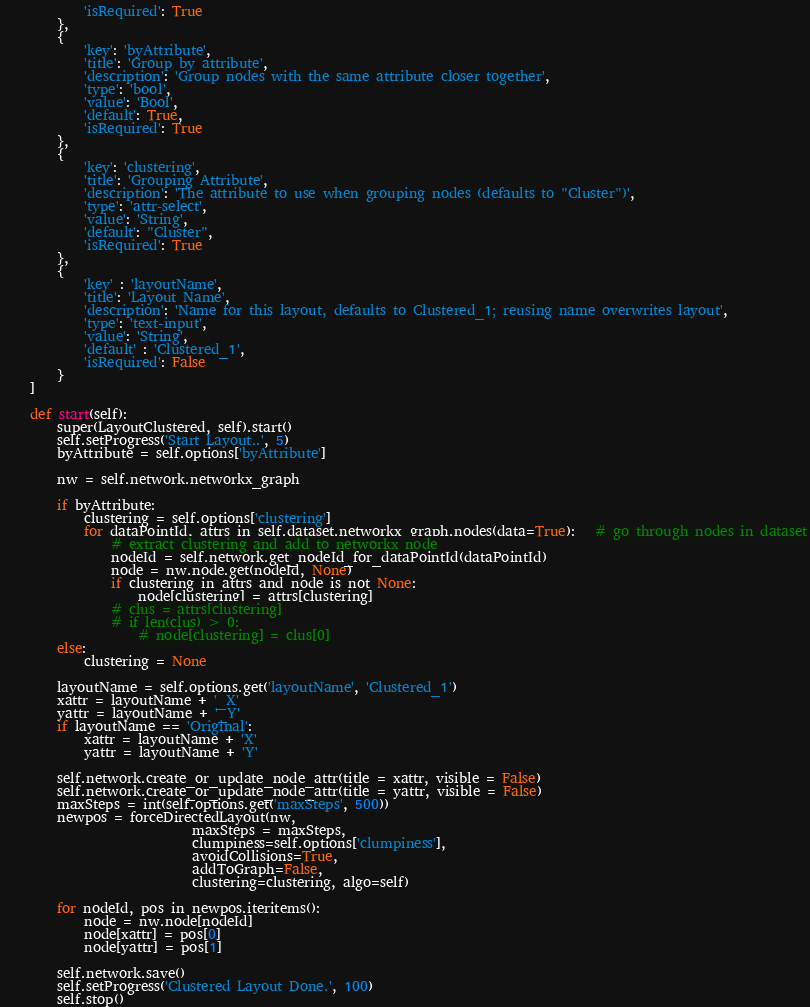<code> <loc_0><loc_0><loc_500><loc_500><_Python_>            'isRequired': True
        },
        {
            'key': 'byAttribute',
            'title': 'Group by attribute',
            'description': 'Group nodes with the same attribute closer together',
            'type': 'bool',
            'value': 'Bool',
            'default': True,
            'isRequired': True
        },
        {
            'key': 'clustering',
            'title': 'Grouping Attribute',
            'description': 'The attribute to use when grouping nodes (defaults to "Cluster")',
            'type': 'attr-select',
            'value': 'String',
            'default': "Cluster",
            'isRequired': True
        },
        {
            'key' : 'layoutName',
            'title': 'Layout Name',
            'description': 'Name for this layout, defaults to Clustered_1; reusing name overwrites layout',
            'type': 'text-input',
            'value': 'String',
            'default' : 'Clustered_1',
            'isRequired': False
        }
    ]

    def start(self):
        super(LayoutClustered, self).start()
        self.setProgress('Start Layout..', 5)
        byAttribute = self.options['byAttribute']

        nw = self.network.networkx_graph

        if byAttribute:
            clustering = self.options['clustering']
            for dataPointId, attrs in self.dataset.networkx_graph.nodes(data=True):   # go through nodes in dataset
                # extract clustering and add to networkx node
                nodeId = self.network.get_nodeId_for_dataPointId(dataPointId)
                node = nw.node.get(nodeId, None)
                if clustering in attrs and node is not None:
                    node[clustering] = attrs[clustering]
                # clus = attrs[clustering]
                # if len(clus) > 0:
                    # node[clustering] = clus[0]
        else:
            clustering = None

        layoutName = self.options.get('layoutName', 'Clustered_1')
        xattr = layoutName + '_X'
        yattr = layoutName + '_Y'
        if layoutName == 'Original':
            xattr = layoutName + 'X'
            yattr = layoutName + 'Y'

        self.network.create_or_update_node_attr(title = xattr, visible = False)
        self.network.create_or_update_node_attr(title = yattr, visible = False)
        maxSteps = int(self.options.get('maxSteps', 500))
        newpos = forceDirectedLayout(nw, 
                            maxSteps = maxSteps,
                            clumpiness=self.options['clumpiness'],
                            avoidCollisions=True,
                            addToGraph=False,
                            clustering=clustering, algo=self)
        
        for nodeId, pos in newpos.iteritems():
            node = nw.node[nodeId]
            node[xattr] = pos[0]
            node[yattr] = pos[1]

        self.network.save()
        self.setProgress('Clustered Layout Done.', 100)
        self.stop()
</code> 